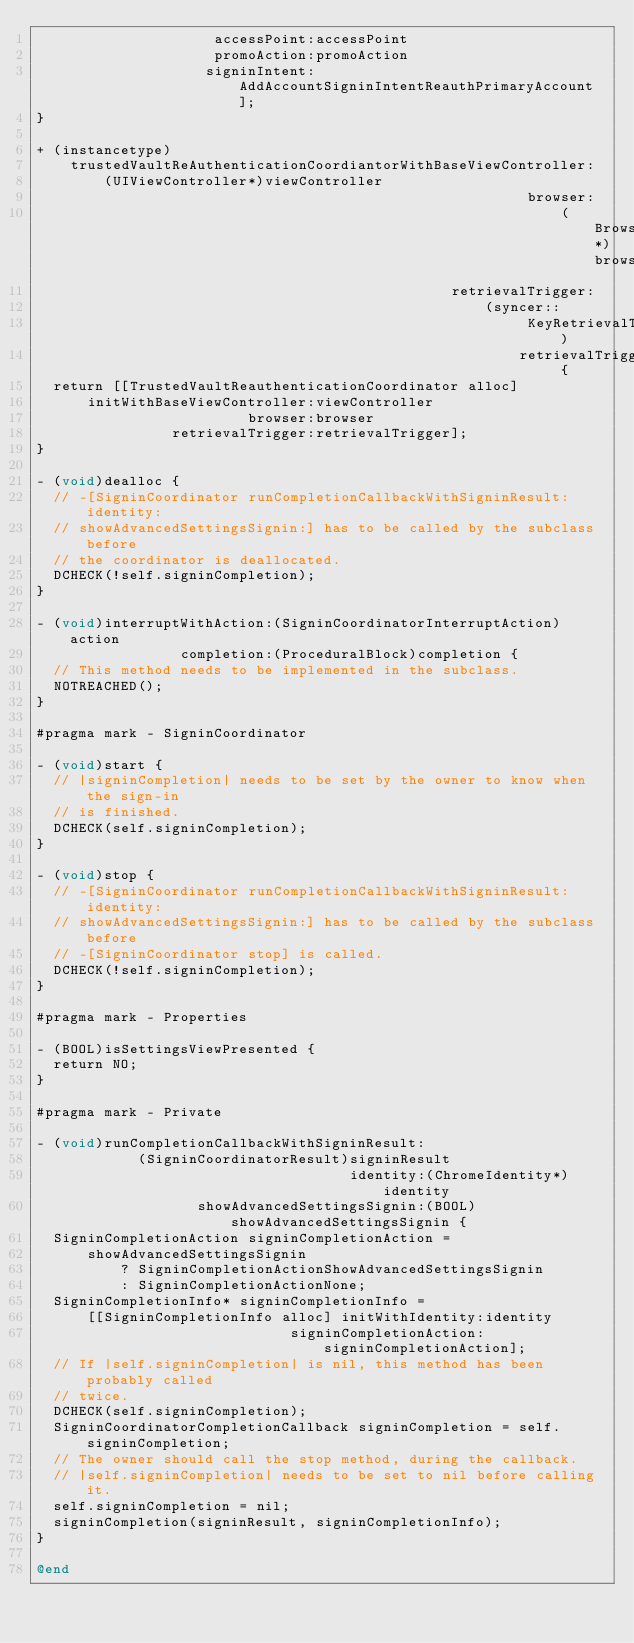<code> <loc_0><loc_0><loc_500><loc_500><_ObjectiveC_>                     accessPoint:accessPoint
                     promoAction:promoAction
                    signinIntent:AddAccountSigninIntentReauthPrimaryAccount];
}

+ (instancetype)
    trustedVaultReAuthenticationCoordiantorWithBaseViewController:
        (UIViewController*)viewController
                                                          browser:
                                                              (Browser*)browser
                                                 retrievalTrigger:
                                                     (syncer::
                                                          KeyRetrievalTriggerForUMA)
                                                         retrievalTrigger {
  return [[TrustedVaultReauthenticationCoordinator alloc]
      initWithBaseViewController:viewController
                         browser:browser
                retrievalTrigger:retrievalTrigger];
}

- (void)dealloc {
  // -[SigninCoordinator runCompletionCallbackWithSigninResult:identity:
  // showAdvancedSettingsSignin:] has to be called by the subclass before
  // the coordinator is deallocated.
  DCHECK(!self.signinCompletion);
}

- (void)interruptWithAction:(SigninCoordinatorInterruptAction)action
                 completion:(ProceduralBlock)completion {
  // This method needs to be implemented in the subclass.
  NOTREACHED();
}

#pragma mark - SigninCoordinator

- (void)start {
  // |signinCompletion| needs to be set by the owner to know when the sign-in
  // is finished.
  DCHECK(self.signinCompletion);
}

- (void)stop {
  // -[SigninCoordinator runCompletionCallbackWithSigninResult:identity:
  // showAdvancedSettingsSignin:] has to be called by the subclass before
  // -[SigninCoordinator stop] is called.
  DCHECK(!self.signinCompletion);
}

#pragma mark - Properties

- (BOOL)isSettingsViewPresented {
  return NO;
}

#pragma mark - Private

- (void)runCompletionCallbackWithSigninResult:
            (SigninCoordinatorResult)signinResult
                                     identity:(ChromeIdentity*)identity
                   showAdvancedSettingsSignin:(BOOL)showAdvancedSettingsSignin {
  SigninCompletionAction signinCompletionAction =
      showAdvancedSettingsSignin
          ? SigninCompletionActionShowAdvancedSettingsSignin
          : SigninCompletionActionNone;
  SigninCompletionInfo* signinCompletionInfo =
      [[SigninCompletionInfo alloc] initWithIdentity:identity
                              signinCompletionAction:signinCompletionAction];
  // If |self.signinCompletion| is nil, this method has been probably called
  // twice.
  DCHECK(self.signinCompletion);
  SigninCoordinatorCompletionCallback signinCompletion = self.signinCompletion;
  // The owner should call the stop method, during the callback.
  // |self.signinCompletion| needs to be set to nil before calling it.
  self.signinCompletion = nil;
  signinCompletion(signinResult, signinCompletionInfo);
}

@end
</code> 